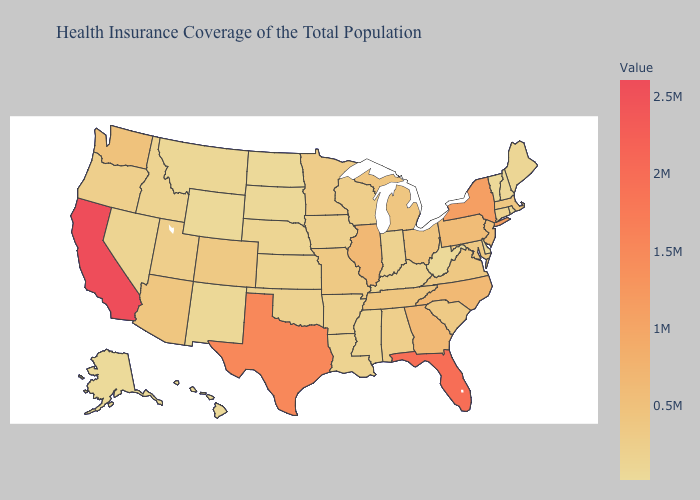Among the states that border California , does Arizona have the highest value?
Be succinct. Yes. Among the states that border Virginia , does West Virginia have the lowest value?
Answer briefly. Yes. Which states have the lowest value in the USA?
Write a very short answer. Alaska. Does California have the highest value in the USA?
Answer briefly. Yes. Which states have the lowest value in the Northeast?
Concise answer only. Vermont. Among the states that border Oklahoma , which have the highest value?
Short answer required. Texas. Among the states that border Texas , does Louisiana have the highest value?
Keep it brief. No. Which states have the highest value in the USA?
Keep it brief. California. 